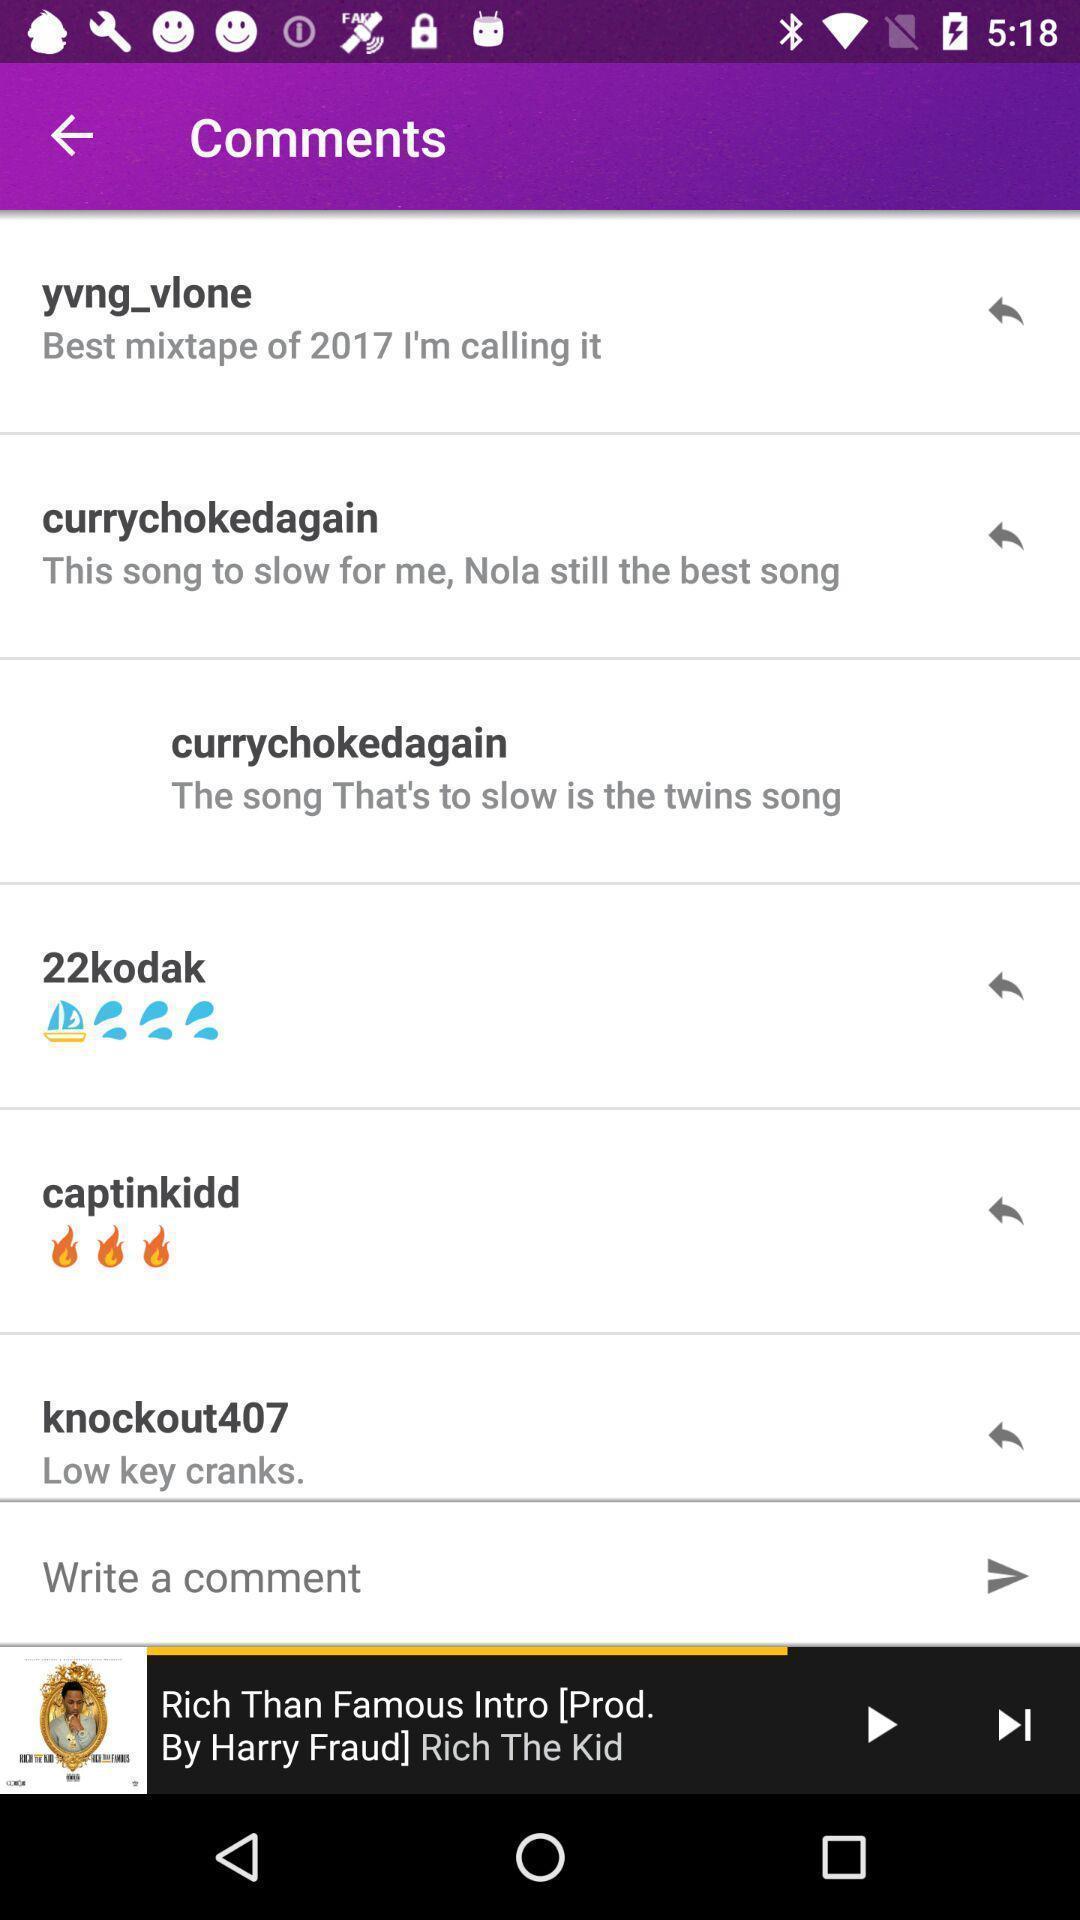Describe the visual elements of this screenshot. Page showing comments with a track playing. 